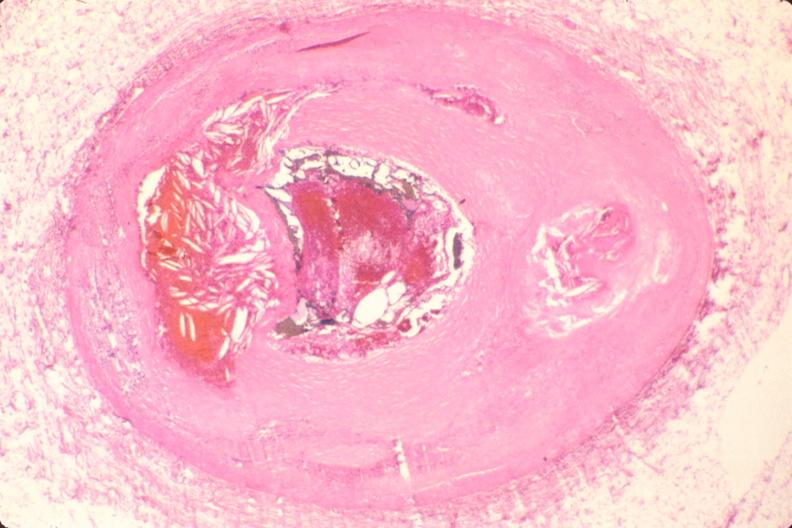s vasculature present?
Answer the question using a single word or phrase. Yes 